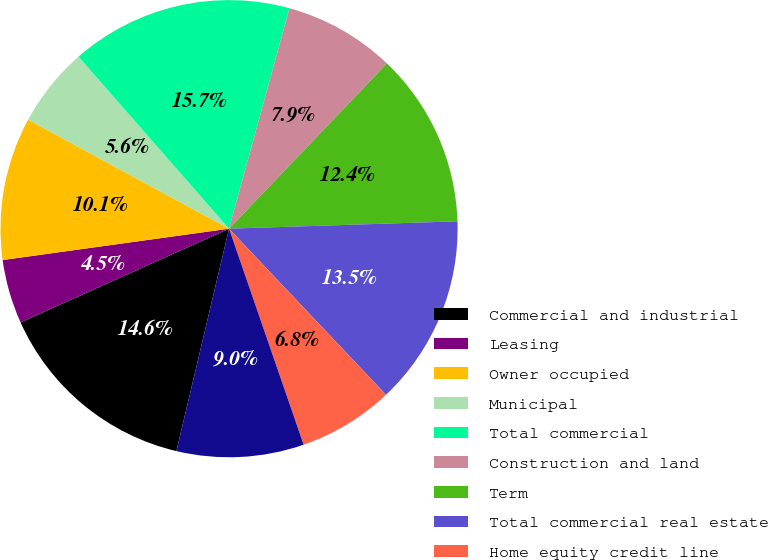<chart> <loc_0><loc_0><loc_500><loc_500><pie_chart><fcel>Commercial and industrial<fcel>Leasing<fcel>Owner occupied<fcel>Municipal<fcel>Total commercial<fcel>Construction and land<fcel>Term<fcel>Total commercial real estate<fcel>Home equity credit line<fcel>1-4 family residential<nl><fcel>14.58%<fcel>4.53%<fcel>10.11%<fcel>5.64%<fcel>15.7%<fcel>7.88%<fcel>12.35%<fcel>13.46%<fcel>6.76%<fcel>8.99%<nl></chart> 